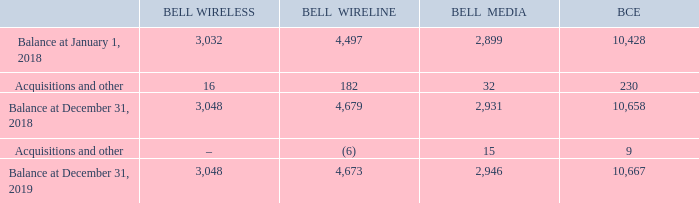Note 19 Goodwill
The following table provides details about the changes in the carrying amounts of goodwill for the years ended December 31, 2019 and 2018. BCE’s groups of CGUs correspond to our reporting segments.
What does BCE's groups of CGUS correspond to? Reporting segments. What is the balance for BCE at December 31, 2018? 10,658. What is the balance for BCE at December 31, 2019? 10,667. What is the change in the Balance comparing January 1, 2018 and December 31, 2019 for BCE? 10,667-10,428
Answer: 239. What is the percentage change in the Balance comparing January 1, 2018 and December 31, 2019 for BCE?
Answer scale should be: percent. (10,667-10,428)/10,428
Answer: 2.29. What is the sum of acquisitions and other for Bell Wireless and Bell Wireline in 2018?  182+16
Answer: 198. 